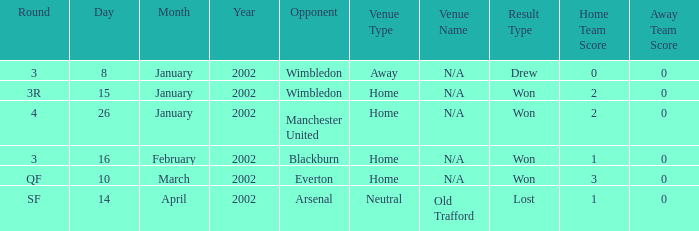What is the Date with an Opponent with wimbledon, and a Result of drew 0-0? 8 January 2002. 